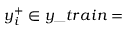Convert formula to latex. <formula><loc_0><loc_0><loc_500><loc_500>y _ { i } ^ { + } \in y \_ t r a i n =</formula> 